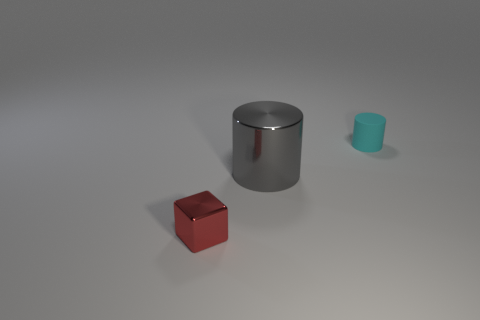Add 1 large cyan metallic blocks. How many objects exist? 4 Subtract all cylinders. How many objects are left? 1 Subtract all small rubber cylinders. Subtract all large gray metal things. How many objects are left? 1 Add 2 metal things. How many metal things are left? 4 Add 2 tiny blue shiny cylinders. How many tiny blue shiny cylinders exist? 2 Subtract 0 red balls. How many objects are left? 3 